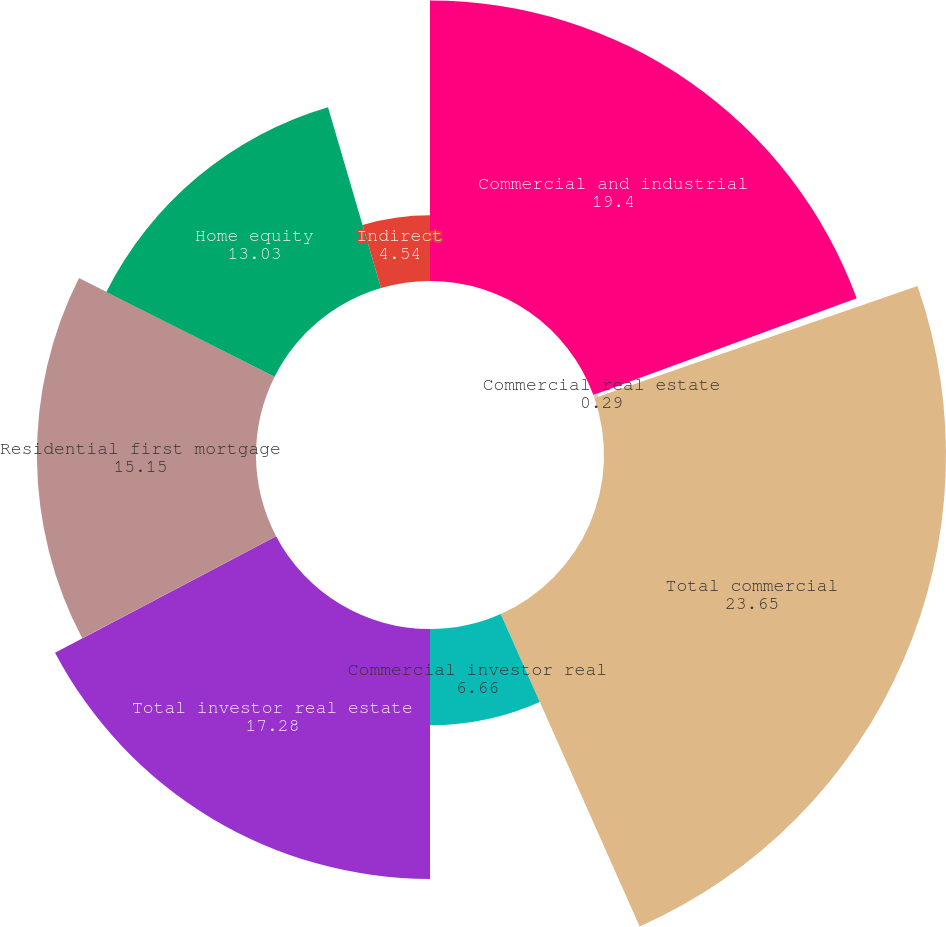Convert chart. <chart><loc_0><loc_0><loc_500><loc_500><pie_chart><fcel>Commercial and industrial<fcel>Commercial real estate<fcel>Total commercial<fcel>Commercial investor real<fcel>Total investor real estate<fcel>Residential first mortgage<fcel>Home equity<fcel>Indirect<nl><fcel>19.4%<fcel>0.29%<fcel>23.65%<fcel>6.66%<fcel>17.28%<fcel>15.15%<fcel>13.03%<fcel>4.54%<nl></chart> 